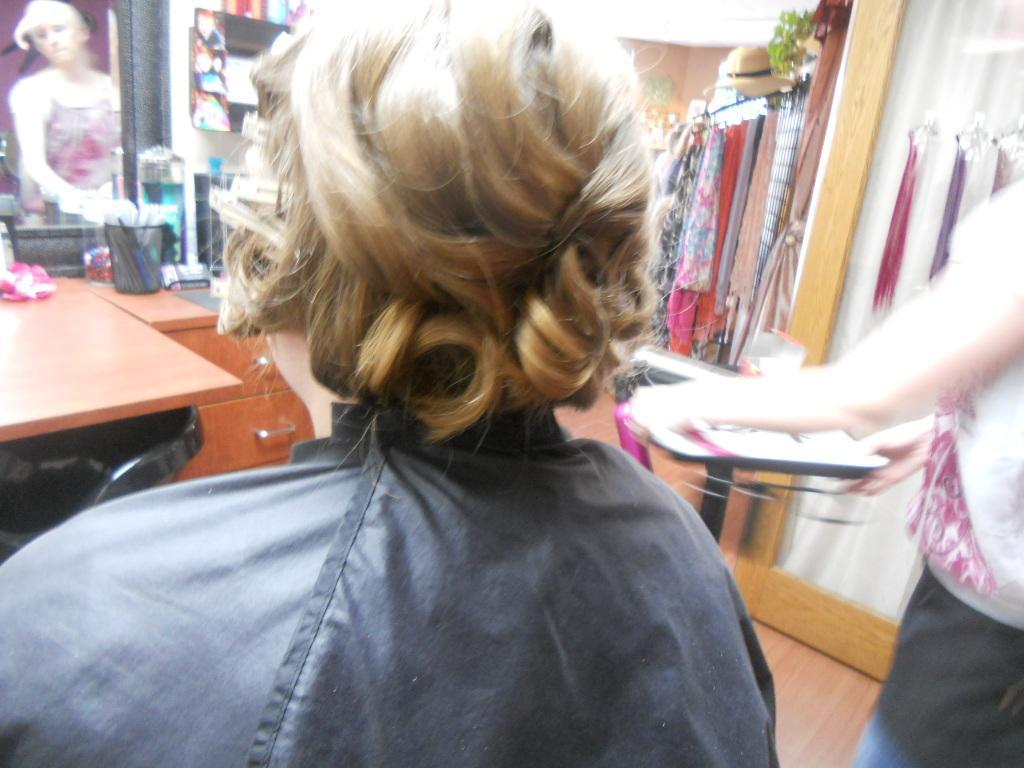Describe this image in one or two sentences. In this image there is a person. Beside to it at the right side of the image there is a person standing and holding a tray. At the left side there is a mirror before it there is a glass. At the right side there are few clothes. 